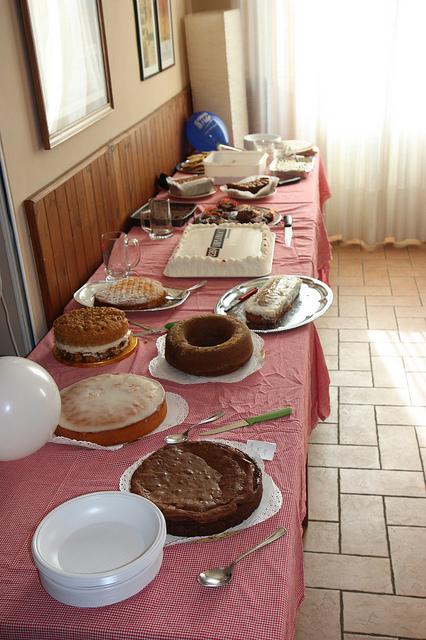Are there any plates on the table?
Keep it brief. Yes. Would this be a suitable meal for a diabetic?
Short answer required. No. How many cakes are there?
Short answer required. 7. 